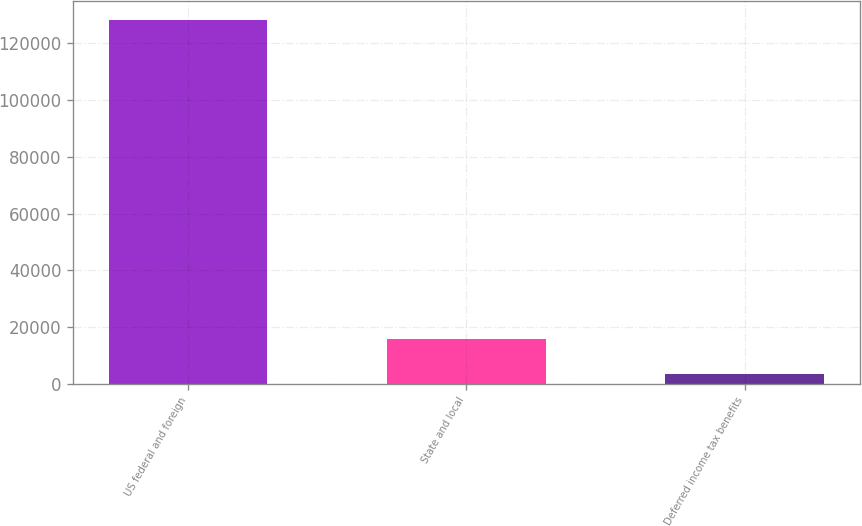Convert chart. <chart><loc_0><loc_0><loc_500><loc_500><bar_chart><fcel>US federal and foreign<fcel>State and local<fcel>Deferred income tax benefits<nl><fcel>128380<fcel>15894.4<fcel>3396<nl></chart> 